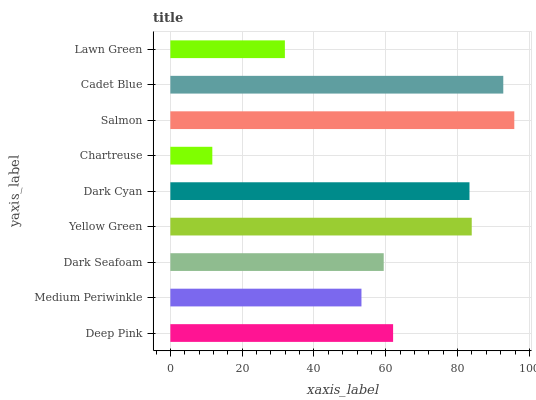Is Chartreuse the minimum?
Answer yes or no. Yes. Is Salmon the maximum?
Answer yes or no. Yes. Is Medium Periwinkle the minimum?
Answer yes or no. No. Is Medium Periwinkle the maximum?
Answer yes or no. No. Is Deep Pink greater than Medium Periwinkle?
Answer yes or no. Yes. Is Medium Periwinkle less than Deep Pink?
Answer yes or no. Yes. Is Medium Periwinkle greater than Deep Pink?
Answer yes or no. No. Is Deep Pink less than Medium Periwinkle?
Answer yes or no. No. Is Deep Pink the high median?
Answer yes or no. Yes. Is Deep Pink the low median?
Answer yes or no. Yes. Is Dark Seafoam the high median?
Answer yes or no. No. Is Salmon the low median?
Answer yes or no. No. 